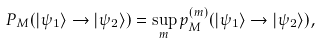Convert formula to latex. <formula><loc_0><loc_0><loc_500><loc_500>P _ { M } ( | \psi _ { 1 } \rangle \rightarrow | \psi _ { 2 } \rangle ) = \sup _ { m } p _ { M } ^ { ( m ) } ( | \psi _ { 1 } \rangle \rightarrow | \psi _ { 2 } \rangle ) ,</formula> 